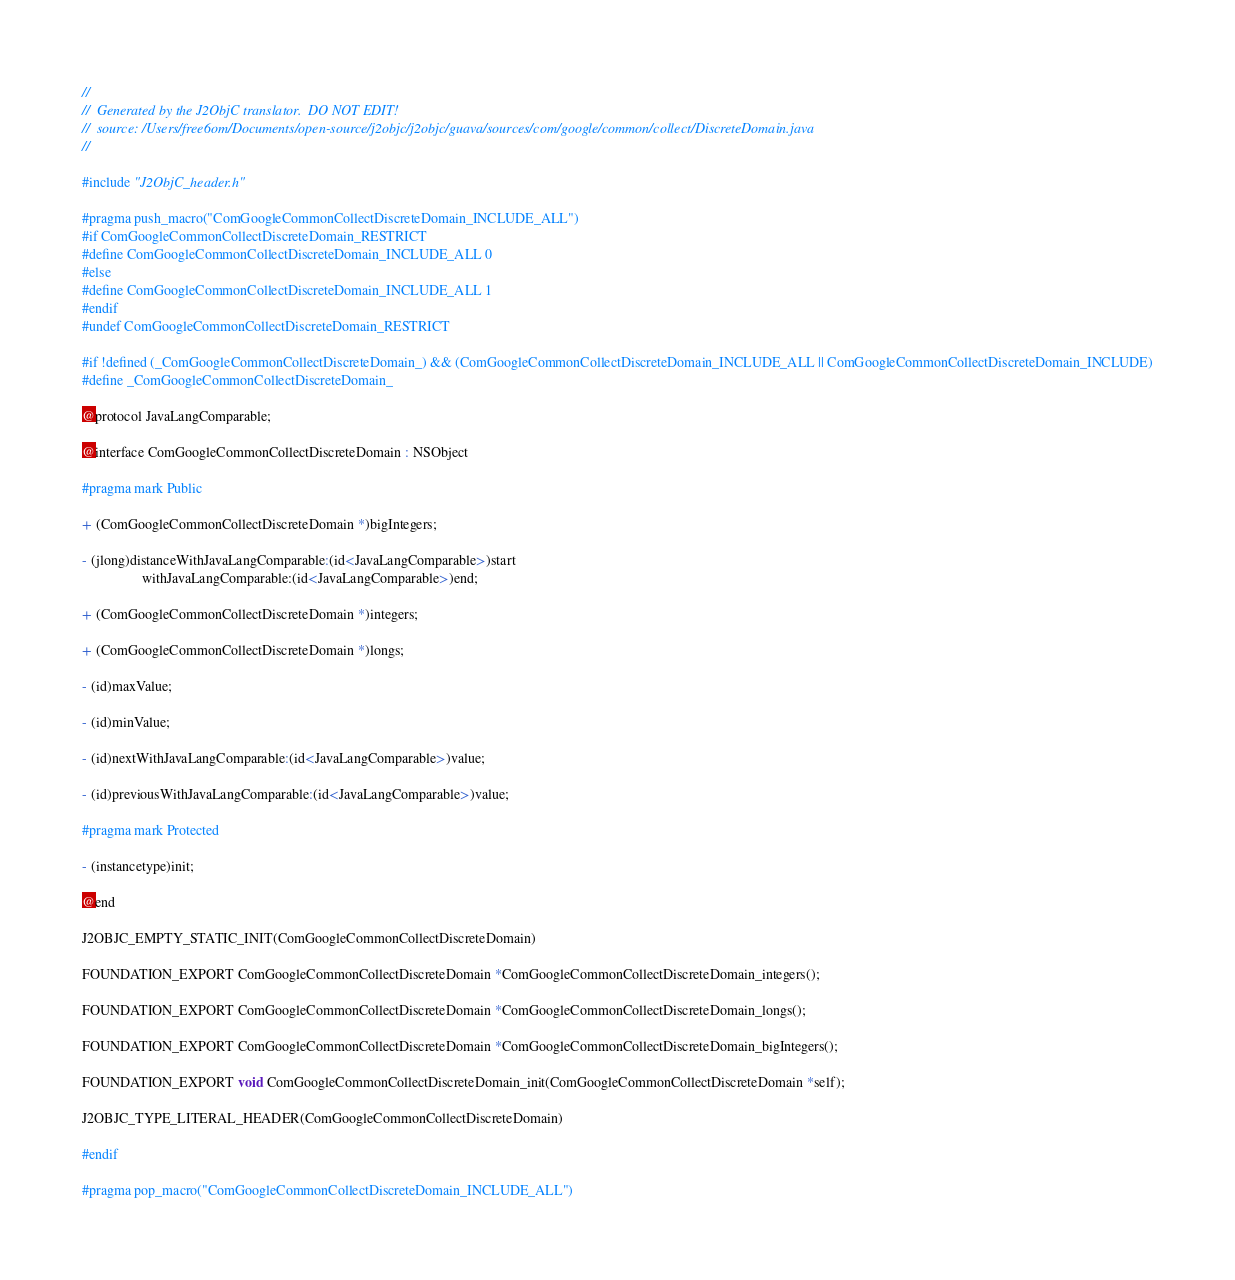<code> <loc_0><loc_0><loc_500><loc_500><_C_>//
//  Generated by the J2ObjC translator.  DO NOT EDIT!
//  source: /Users/free6om/Documents/open-source/j2objc/j2objc/guava/sources/com/google/common/collect/DiscreteDomain.java
//

#include "J2ObjC_header.h"

#pragma push_macro("ComGoogleCommonCollectDiscreteDomain_INCLUDE_ALL")
#if ComGoogleCommonCollectDiscreteDomain_RESTRICT
#define ComGoogleCommonCollectDiscreteDomain_INCLUDE_ALL 0
#else
#define ComGoogleCommonCollectDiscreteDomain_INCLUDE_ALL 1
#endif
#undef ComGoogleCommonCollectDiscreteDomain_RESTRICT

#if !defined (_ComGoogleCommonCollectDiscreteDomain_) && (ComGoogleCommonCollectDiscreteDomain_INCLUDE_ALL || ComGoogleCommonCollectDiscreteDomain_INCLUDE)
#define _ComGoogleCommonCollectDiscreteDomain_

@protocol JavaLangComparable;

@interface ComGoogleCommonCollectDiscreteDomain : NSObject

#pragma mark Public

+ (ComGoogleCommonCollectDiscreteDomain *)bigIntegers;

- (jlong)distanceWithJavaLangComparable:(id<JavaLangComparable>)start
                 withJavaLangComparable:(id<JavaLangComparable>)end;

+ (ComGoogleCommonCollectDiscreteDomain *)integers;

+ (ComGoogleCommonCollectDiscreteDomain *)longs;

- (id)maxValue;

- (id)minValue;

- (id)nextWithJavaLangComparable:(id<JavaLangComparable>)value;

- (id)previousWithJavaLangComparable:(id<JavaLangComparable>)value;

#pragma mark Protected

- (instancetype)init;

@end

J2OBJC_EMPTY_STATIC_INIT(ComGoogleCommonCollectDiscreteDomain)

FOUNDATION_EXPORT ComGoogleCommonCollectDiscreteDomain *ComGoogleCommonCollectDiscreteDomain_integers();

FOUNDATION_EXPORT ComGoogleCommonCollectDiscreteDomain *ComGoogleCommonCollectDiscreteDomain_longs();

FOUNDATION_EXPORT ComGoogleCommonCollectDiscreteDomain *ComGoogleCommonCollectDiscreteDomain_bigIntegers();

FOUNDATION_EXPORT void ComGoogleCommonCollectDiscreteDomain_init(ComGoogleCommonCollectDiscreteDomain *self);

J2OBJC_TYPE_LITERAL_HEADER(ComGoogleCommonCollectDiscreteDomain)

#endif

#pragma pop_macro("ComGoogleCommonCollectDiscreteDomain_INCLUDE_ALL")
</code> 